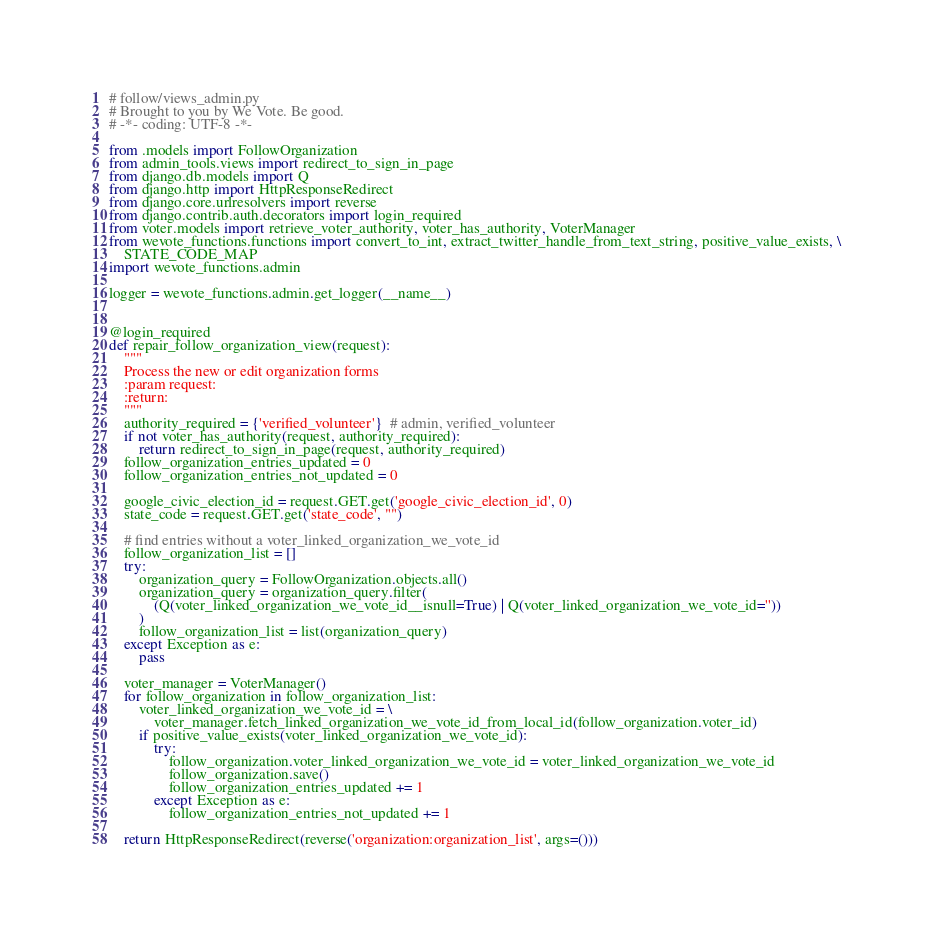Convert code to text. <code><loc_0><loc_0><loc_500><loc_500><_Python_># follow/views_admin.py
# Brought to you by We Vote. Be good.
# -*- coding: UTF-8 -*-

from .models import FollowOrganization
from admin_tools.views import redirect_to_sign_in_page
from django.db.models import Q
from django.http import HttpResponseRedirect
from django.core.urlresolvers import reverse
from django.contrib.auth.decorators import login_required
from voter.models import retrieve_voter_authority, voter_has_authority, VoterManager
from wevote_functions.functions import convert_to_int, extract_twitter_handle_from_text_string, positive_value_exists, \
    STATE_CODE_MAP
import wevote_functions.admin

logger = wevote_functions.admin.get_logger(__name__)


@login_required
def repair_follow_organization_view(request):
    """
    Process the new or edit organization forms
    :param request:
    :return:
    """
    authority_required = {'verified_volunteer'}  # admin, verified_volunteer
    if not voter_has_authority(request, authority_required):
        return redirect_to_sign_in_page(request, authority_required)
    follow_organization_entries_updated = 0
    follow_organization_entries_not_updated = 0

    google_civic_election_id = request.GET.get('google_civic_election_id', 0)
    state_code = request.GET.get('state_code', "")

    # find entries without a voter_linked_organization_we_vote_id
    follow_organization_list = []
    try:
        organization_query = FollowOrganization.objects.all()
        organization_query = organization_query.filter(
            (Q(voter_linked_organization_we_vote_id__isnull=True) | Q(voter_linked_organization_we_vote_id=''))
        )
        follow_organization_list = list(organization_query)
    except Exception as e:
        pass

    voter_manager = VoterManager()
    for follow_organization in follow_organization_list:
        voter_linked_organization_we_vote_id = \
            voter_manager.fetch_linked_organization_we_vote_id_from_local_id(follow_organization.voter_id)
        if positive_value_exists(voter_linked_organization_we_vote_id):
            try:
                follow_organization.voter_linked_organization_we_vote_id = voter_linked_organization_we_vote_id
                follow_organization.save()
                follow_organization_entries_updated += 1
            except Exception as e:
                follow_organization_entries_not_updated += 1

    return HttpResponseRedirect(reverse('organization:organization_list', args=()))
</code> 